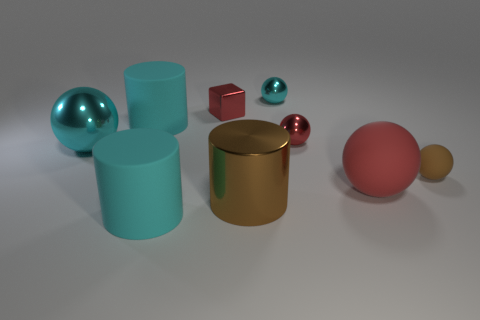Is the brown cylinder the same size as the brown matte sphere?
Offer a terse response. No. What color is the small metal cube?
Ensure brevity in your answer.  Red. How many objects are either shiny blocks or big cyan rubber balls?
Your answer should be compact. 1. Are there any other tiny shiny objects that have the same shape as the small cyan object?
Offer a terse response. Yes. Is the color of the metal thing in front of the big cyan metal ball the same as the tiny rubber object?
Give a very brief answer. Yes. What shape is the matte object behind the big sphere that is behind the large red rubber sphere?
Keep it short and to the point. Cylinder. Are there any matte spheres of the same size as the metal cylinder?
Keep it short and to the point. Yes. Is the number of large cyan metal spheres less than the number of metallic balls?
Provide a short and direct response. Yes. There is a big metallic thing that is right of the cyan metallic sphere that is in front of the large cylinder that is behind the large brown shiny thing; what shape is it?
Your answer should be very brief. Cylinder. How many objects are either small red things on the left side of the large brown object or things that are in front of the brown matte thing?
Your answer should be very brief. 4. 